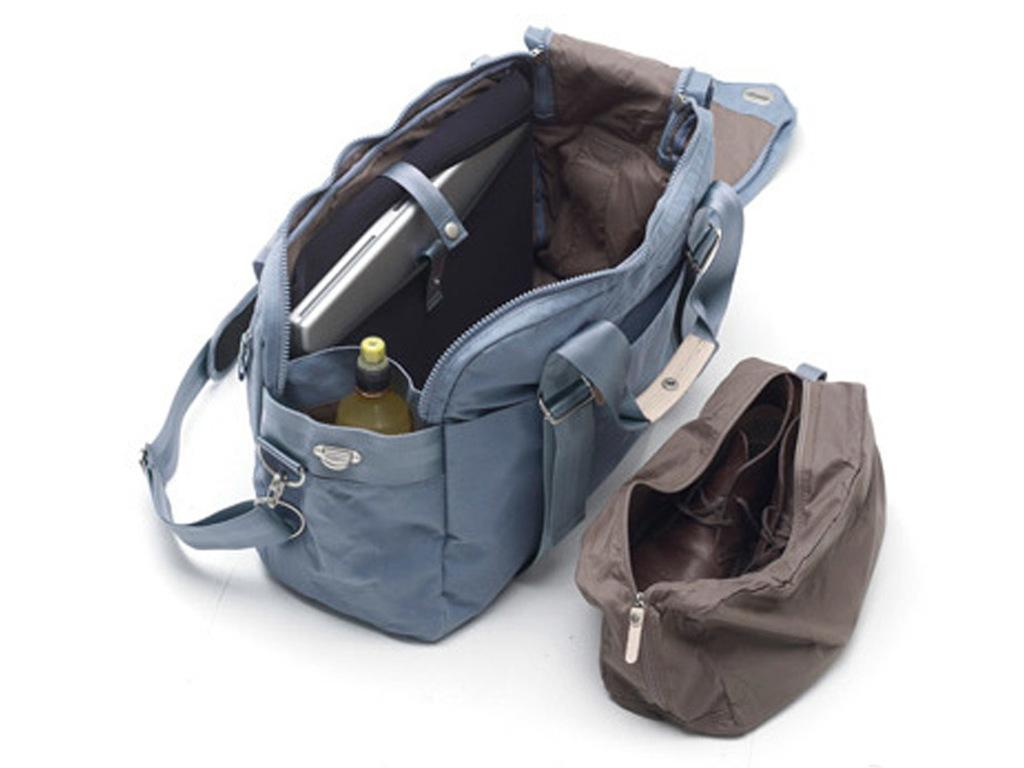What type of items can be seen in the image? There is footwear, a bottle, and a laptop in the image. How are these items being stored or carried? The bags containing these items are visible. What is the color of the background in the image? The background of the image is white. How many pickles are visible in the image? There are no pickles present in the image. What type of boats can be seen in the image? There are no boats present in the image. 